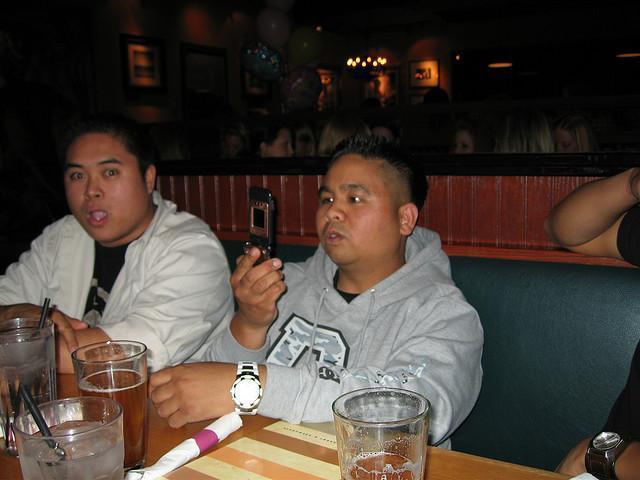How many cups can be seen?
Give a very brief answer. 4. How many people are in the picture?
Give a very brief answer. 4. 